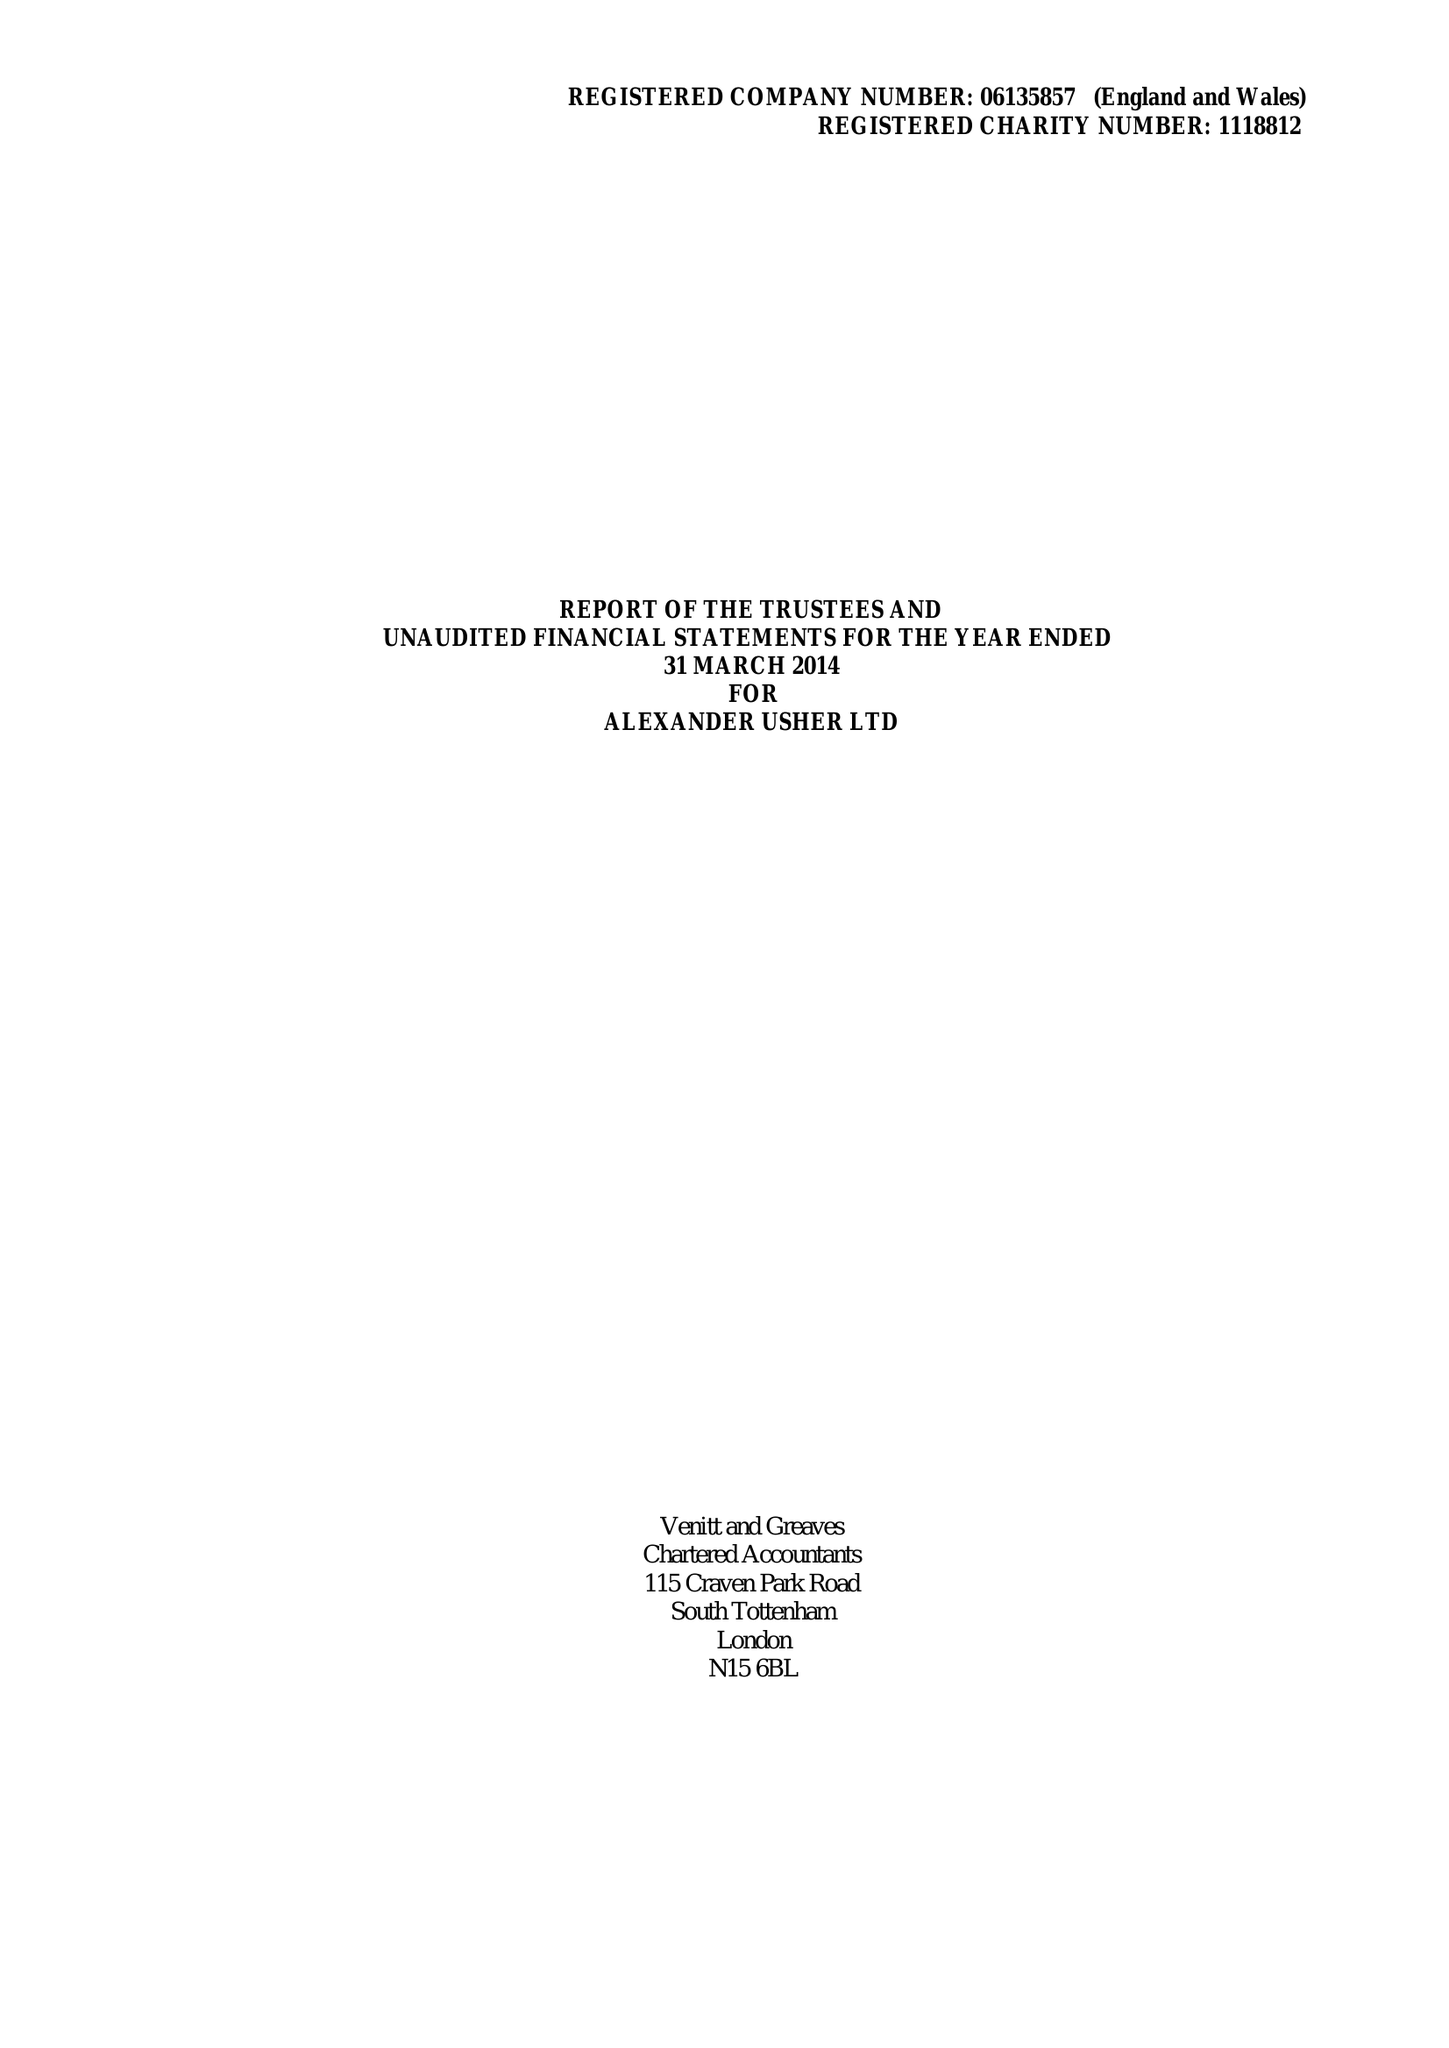What is the value for the income_annually_in_british_pounds?
Answer the question using a single word or phrase. 296158.00 